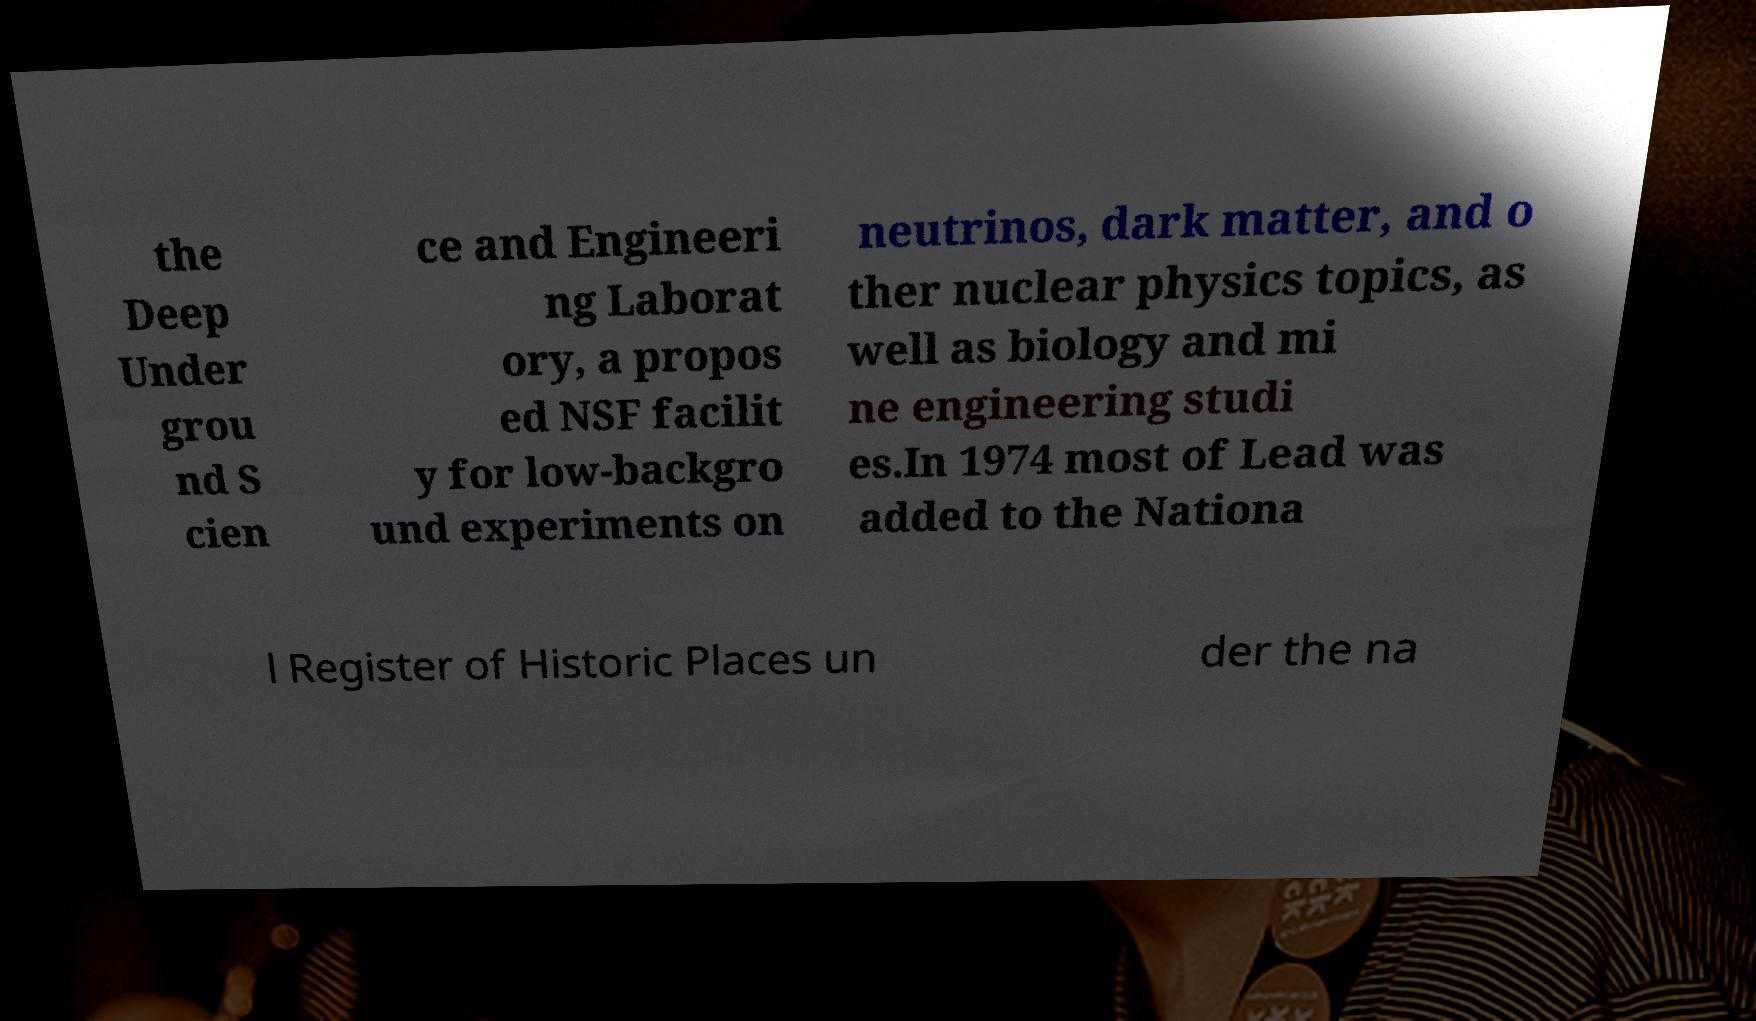For documentation purposes, I need the text within this image transcribed. Could you provide that? the Deep Under grou nd S cien ce and Engineeri ng Laborat ory, a propos ed NSF facilit y for low-backgro und experiments on neutrinos, dark matter, and o ther nuclear physics topics, as well as biology and mi ne engineering studi es.In 1974 most of Lead was added to the Nationa l Register of Historic Places un der the na 